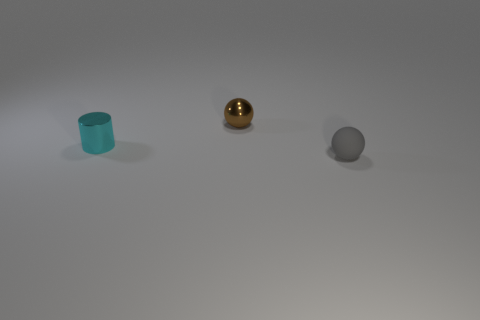Is there any other thing that is the same material as the small gray object?
Your answer should be very brief. No. How many tiny objects are left of the tiny gray rubber ball and to the right of the tiny cyan cylinder?
Ensure brevity in your answer.  1. Are there more large gray metallic balls than tiny brown metallic spheres?
Your answer should be very brief. No. How many other objects are the same shape as the cyan object?
Offer a terse response. 0. Is the tiny cylinder the same color as the rubber object?
Your answer should be compact. No. There is a tiny thing that is both in front of the brown metal ball and behind the tiny gray object; what material is it made of?
Provide a succinct answer. Metal. The cyan shiny thing has what size?
Ensure brevity in your answer.  Small. How many spheres are on the left side of the small ball in front of the tiny sphere behind the gray rubber thing?
Offer a terse response. 1. What is the shape of the tiny object left of the small metal thing that is behind the metal cylinder?
Make the answer very short. Cylinder. There is another metallic thing that is the same shape as the gray thing; what size is it?
Ensure brevity in your answer.  Small. 